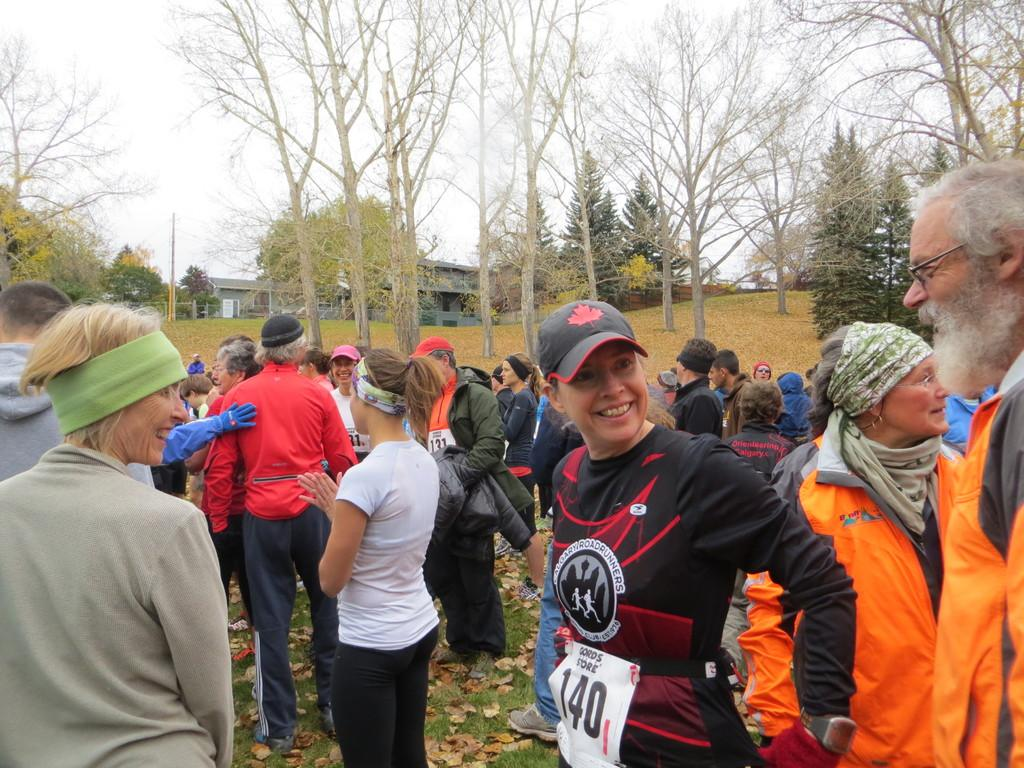What is the setting of the image? There are people standing on the ground in the image. Can you describe the people in the image? There are men and women in the image. What can be seen in the background of the image? There are trees, houses, and the sky visible in the background of the image. What is the weight of the cannon located on the seashore in the image? There is no cannon or seashore present in the image. 